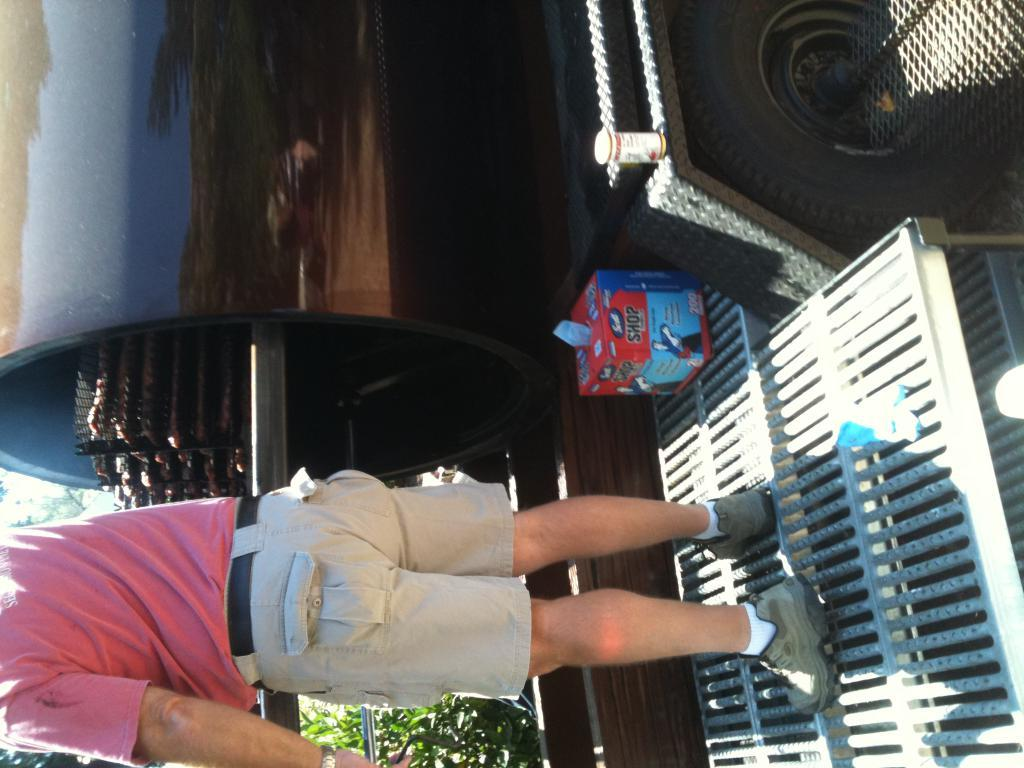What is the person in the image doing? The person is standing on a metal rod in the image. What can be seen in the background of the image? There is a vehicle, a fence, objects, and plants in the background of the image. What is the weather like in the image? The image appears to have been taken on a sunny day. Where are the rabbits playing in the image? There are no rabbits present in the image. Is there a river visible in the image? There is no river visible in the image. 